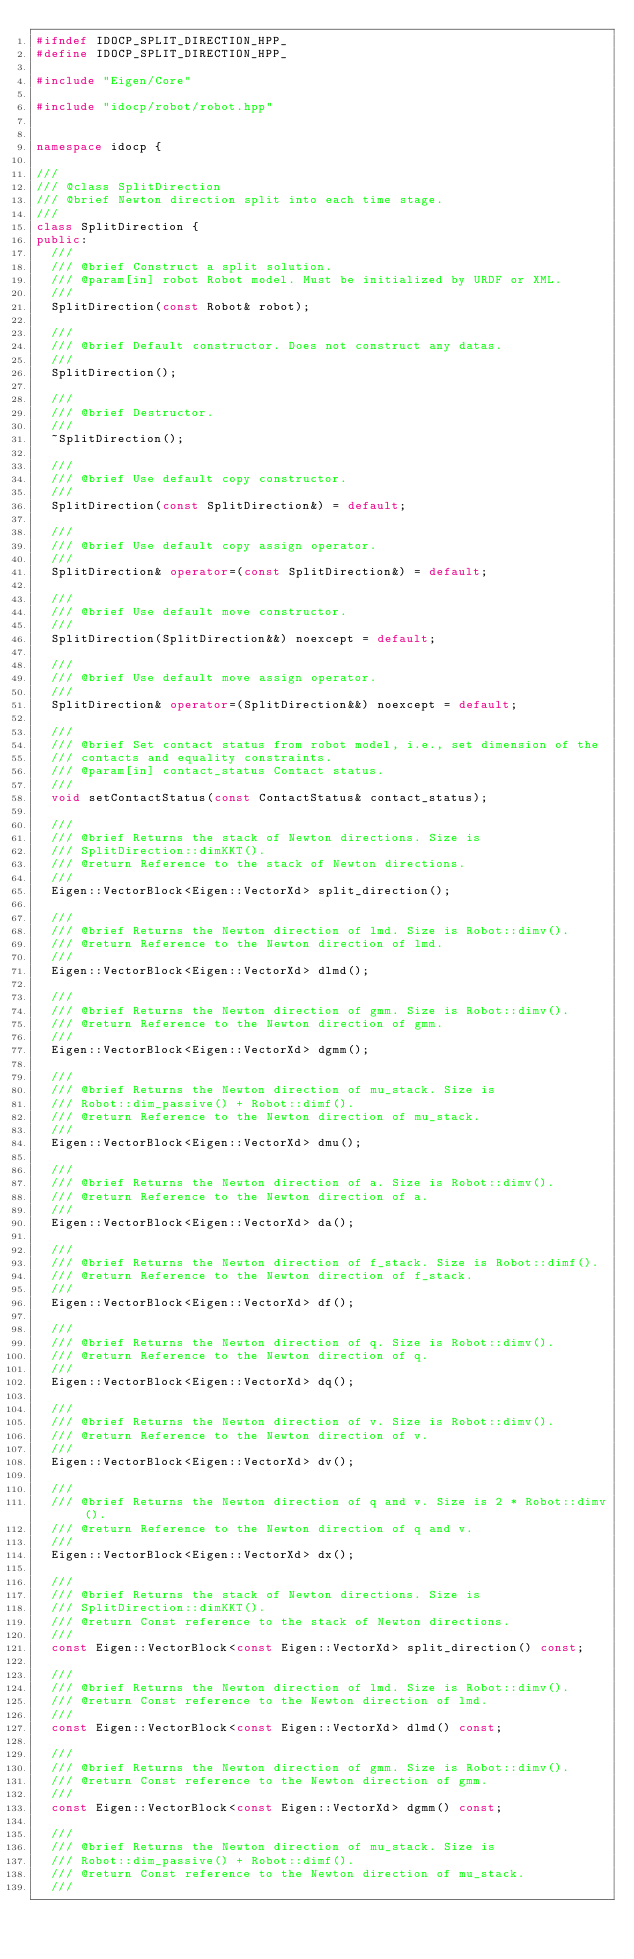Convert code to text. <code><loc_0><loc_0><loc_500><loc_500><_C++_>#ifndef IDOCP_SPLIT_DIRECTION_HPP_
#define IDOCP_SPLIT_DIRECTION_HPP_

#include "Eigen/Core"

#include "idocp/robot/robot.hpp"


namespace idocp {

///
/// @class SplitDirection
/// @brief Newton direction split into each time stage. 
///
class SplitDirection {
public:
  ///
  /// @brief Construct a split solution.
  /// @param[in] robot Robot model. Must be initialized by URDF or XML.
  ///
  SplitDirection(const Robot& robot);

  ///
  /// @brief Default constructor. Does not construct any datas. 
  ///
  SplitDirection();

  ///
  /// @brief Destructor. 
  ///
  ~SplitDirection();

  ///
  /// @brief Use default copy constructor. 
  ///
  SplitDirection(const SplitDirection&) = default;

  ///
  /// @brief Use default copy assign operator. 
  ///
  SplitDirection& operator=(const SplitDirection&) = default;
 
  ///
  /// @brief Use default move constructor. 
  ///
  SplitDirection(SplitDirection&&) noexcept = default;

  ///
  /// @brief Use default move assign operator. 
  ///
  SplitDirection& operator=(SplitDirection&&) noexcept = default;

  ///
  /// @brief Set contact status from robot model, i.e., set dimension of the 
  /// contacts and equality constraints.
  /// @param[in] contact_status Contact status.
  ///
  void setContactStatus(const ContactStatus& contact_status);

  ///
  /// @brief Returns the stack of Newton directions. Size is 
  /// SplitDirection::dimKKT().
  /// @return Reference to the stack of Newton directions.
  ///
  Eigen::VectorBlock<Eigen::VectorXd> split_direction();

  ///
  /// @brief Returns the Newton direction of lmd. Size is Robot::dimv().
  /// @return Reference to the Newton direction of lmd.
  ///
  Eigen::VectorBlock<Eigen::VectorXd> dlmd();

  ///
  /// @brief Returns the Newton direction of gmm. Size is Robot::dimv().
  /// @return Reference to the Newton direction of gmm.
  ///
  Eigen::VectorBlock<Eigen::VectorXd> dgmm();

  ///
  /// @brief Returns the Newton direction of mu_stack. Size is 
  /// Robot::dim_passive() + Robot::dimf().
  /// @return Reference to the Newton direction of mu_stack.
  ///
  Eigen::VectorBlock<Eigen::VectorXd> dmu();

  ///
  /// @brief Returns the Newton direction of a. Size is Robot::dimv().
  /// @return Reference to the Newton direction of a.
  ///
  Eigen::VectorBlock<Eigen::VectorXd> da();

  ///
  /// @brief Returns the Newton direction of f_stack. Size is Robot::dimf().
  /// @return Reference to the Newton direction of f_stack.
  ///
  Eigen::VectorBlock<Eigen::VectorXd> df();

  ///
  /// @brief Returns the Newton direction of q. Size is Robot::dimv().
  /// @return Reference to the Newton direction of q.
  ///
  Eigen::VectorBlock<Eigen::VectorXd> dq();

  ///
  /// @brief Returns the Newton direction of v. Size is Robot::dimv().
  /// @return Reference to the Newton direction of v.
  ///
  Eigen::VectorBlock<Eigen::VectorXd> dv();

  ///
  /// @brief Returns the Newton direction of q and v. Size is 2 * Robot::dimv().
  /// @return Reference to the Newton direction of q and v.
  ///
  Eigen::VectorBlock<Eigen::VectorXd> dx();

  ///
  /// @brief Returns the stack of Newton directions. Size is 
  /// SplitDirection::dimKKT().
  /// @return Const reference to the stack of Newton directions.
  ///
  const Eigen::VectorBlock<const Eigen::VectorXd> split_direction() const;

  ///
  /// @brief Returns the Newton direction of lmd. Size is Robot::dimv().
  /// @return Const reference to the Newton direction of lmd.
  ///
  const Eigen::VectorBlock<const Eigen::VectorXd> dlmd() const;

  ///
  /// @brief Returns the Newton direction of gmm. Size is Robot::dimv().
  /// @return Const reference to the Newton direction of gmm.
  ///
  const Eigen::VectorBlock<const Eigen::VectorXd> dgmm() const;

  ///
  /// @brief Returns the Newton direction of mu_stack. Size is 
  /// Robot::dim_passive() + Robot::dimf().
  /// @return Const reference to the Newton direction of mu_stack.
  ///</code> 